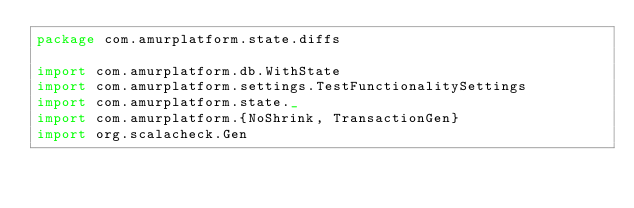<code> <loc_0><loc_0><loc_500><loc_500><_Scala_>package com.amurplatform.state.diffs

import com.amurplatform.db.WithState
import com.amurplatform.settings.TestFunctionalitySettings
import com.amurplatform.state._
import com.amurplatform.{NoShrink, TransactionGen}
import org.scalacheck.Gen</code> 